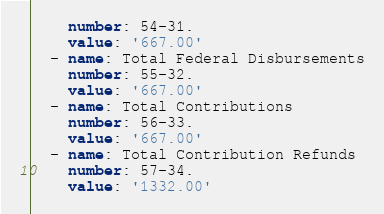Convert code to text. <code><loc_0><loc_0><loc_500><loc_500><_YAML_>    number: 54-31.
    value: '667.00'
  - name: Total Federal Disbursements
    number: 55-32.
    value: '667.00'
  - name: Total Contributions
    number: 56-33.
    value: '667.00'
  - name: Total Contribution Refunds
    number: 57-34.
    value: '1332.00'</code> 